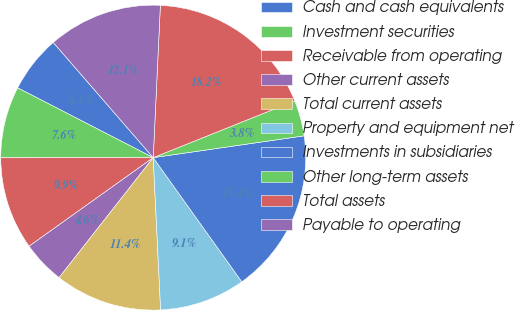<chart> <loc_0><loc_0><loc_500><loc_500><pie_chart><fcel>Cash and cash equivalents<fcel>Investment securities<fcel>Receivable from operating<fcel>Other current assets<fcel>Total current assets<fcel>Property and equipment net<fcel>Investments in subsidiaries<fcel>Other long-term assets<fcel>Total assets<fcel>Payable to operating<nl><fcel>6.06%<fcel>7.58%<fcel>9.85%<fcel>4.55%<fcel>11.36%<fcel>9.09%<fcel>17.42%<fcel>3.79%<fcel>18.18%<fcel>12.12%<nl></chart> 